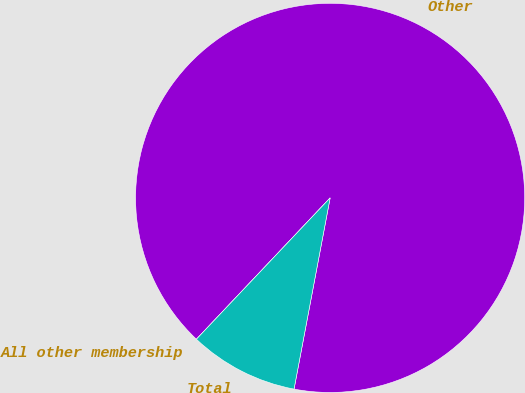Convert chart to OTSL. <chart><loc_0><loc_0><loc_500><loc_500><pie_chart><fcel>Other<fcel>All other membership<fcel>Total<nl><fcel>90.91%<fcel>0.0%<fcel>9.09%<nl></chart> 